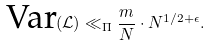<formula> <loc_0><loc_0><loc_500><loc_500>\text {Var} ( \mathcal { L } ) \ll _ { \Pi } \frac { m } { N } \cdot N ^ { 1 / 2 + \epsilon } .</formula> 